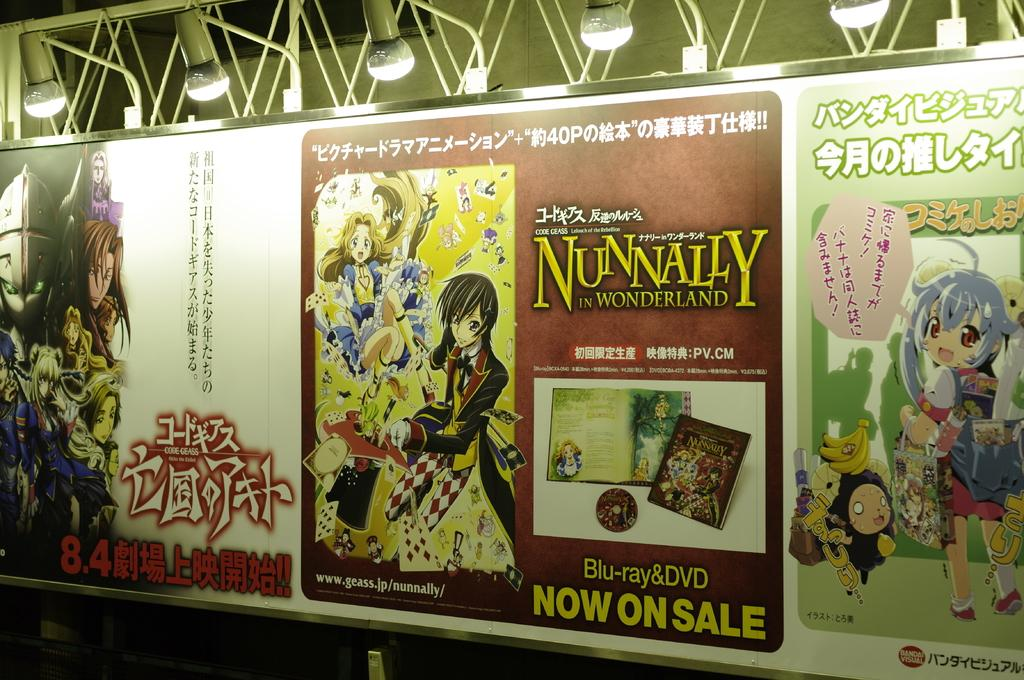<image>
Create a compact narrative representing the image presented. Some posters, one of which has the words Now on Sale at the bottom. 